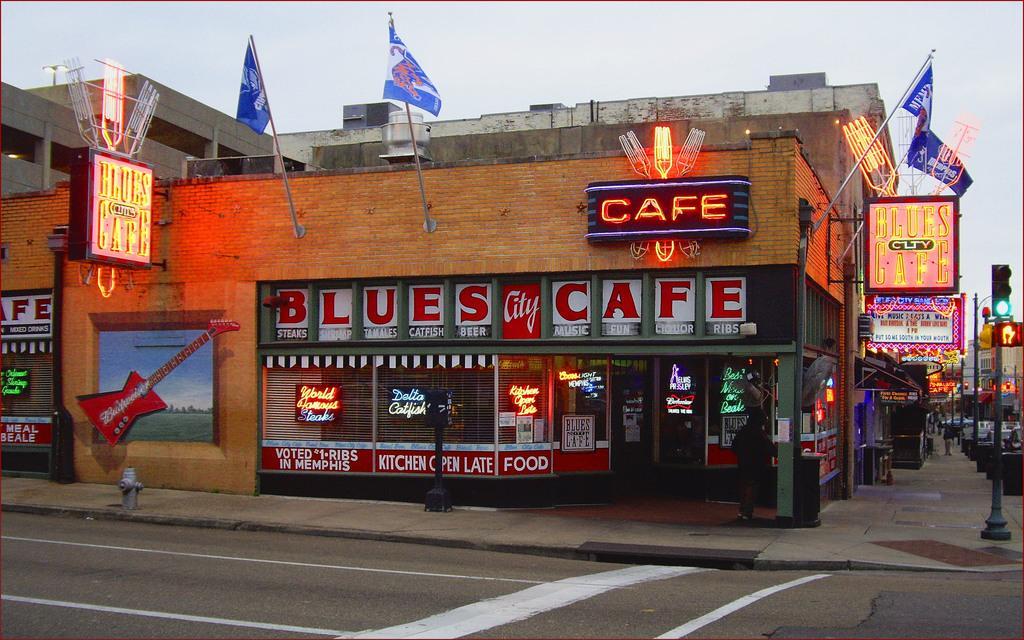How would you summarize this image in a sentence or two? In this image we can see there is a building with lights on it. Behind that there is a pole with traffic lights. 